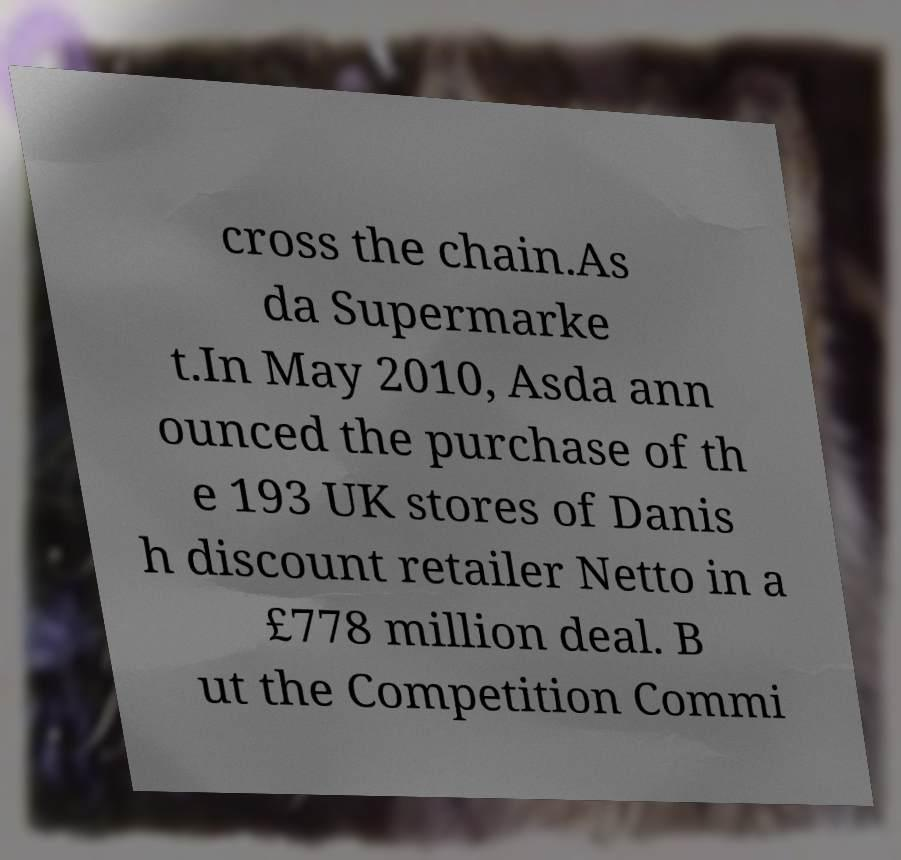Please identify and transcribe the text found in this image. cross the chain.As da Supermarke t.In May 2010, Asda ann ounced the purchase of th e 193 UK stores of Danis h discount retailer Netto in a £778 million deal. B ut the Competition Commi 